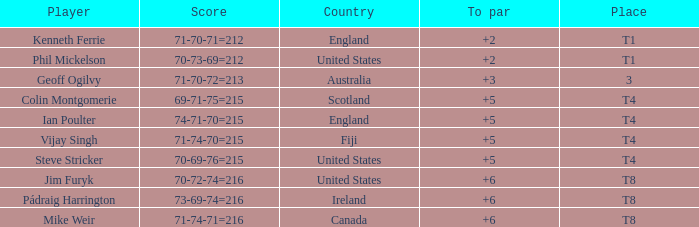What athlete held the spot of t1 in to par and recorded a score of 70-73-69=212? 2.0. 